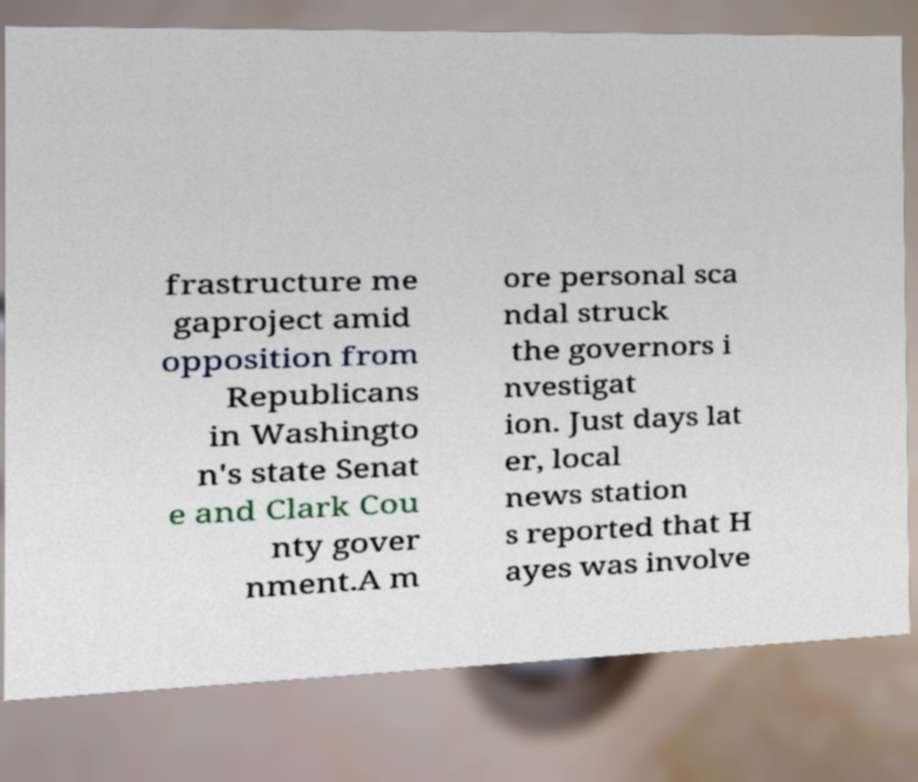Can you accurately transcribe the text from the provided image for me? frastructure me gaproject amid opposition from Republicans in Washingto n's state Senat e and Clark Cou nty gover nment.A m ore personal sca ndal struck the governors i nvestigat ion. Just days lat er, local news station s reported that H ayes was involve 